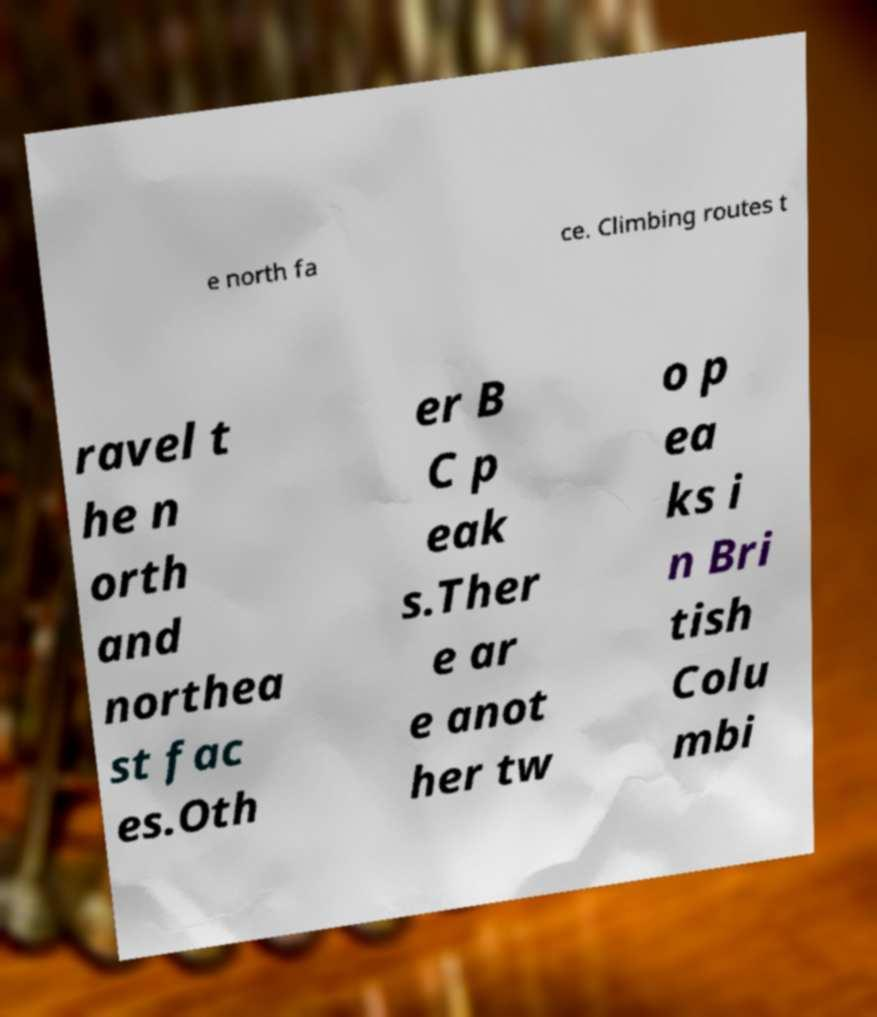Please read and relay the text visible in this image. What does it say? e north fa ce. Climbing routes t ravel t he n orth and northea st fac es.Oth er B C p eak s.Ther e ar e anot her tw o p ea ks i n Bri tish Colu mbi 